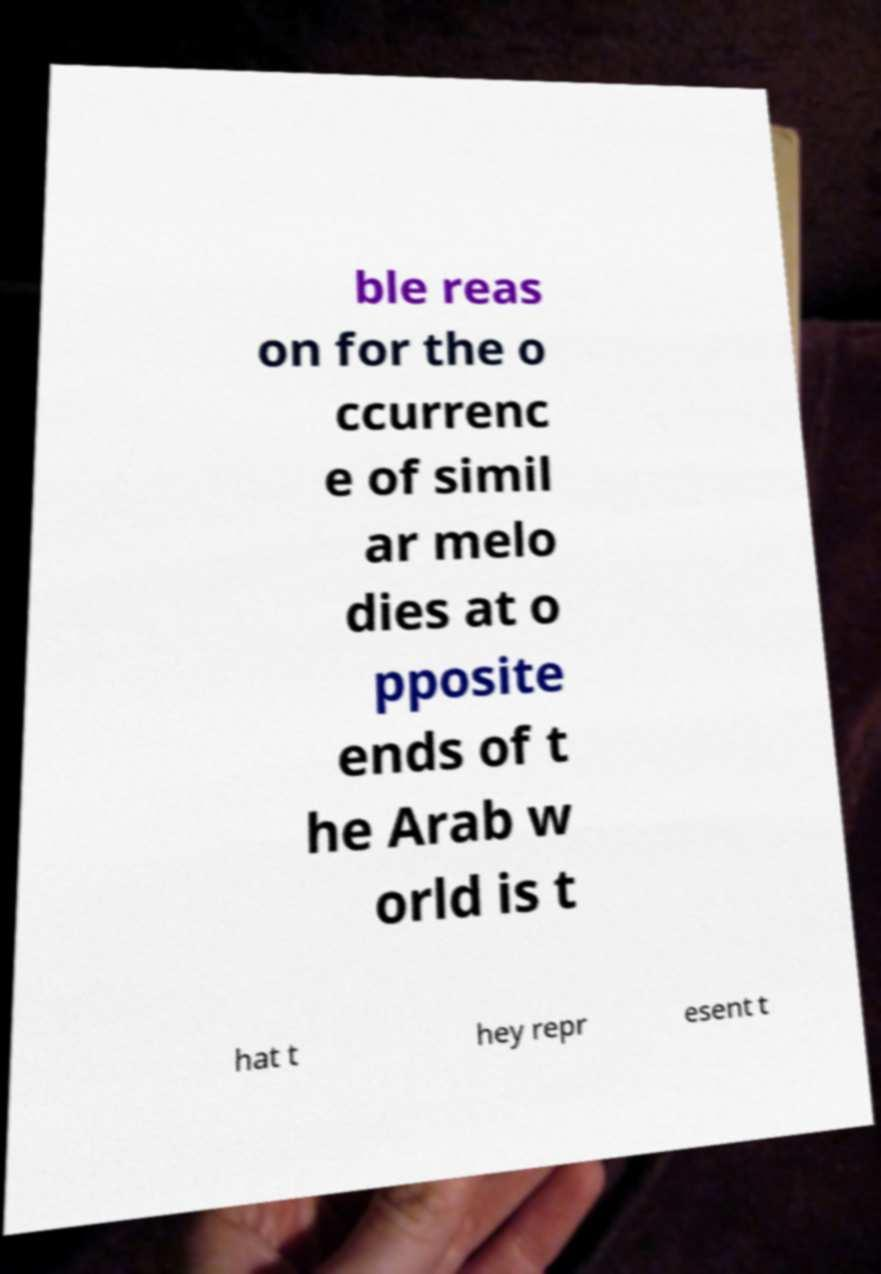What messages or text are displayed in this image? I need them in a readable, typed format. ble reas on for the o ccurrenc e of simil ar melo dies at o pposite ends of t he Arab w orld is t hat t hey repr esent t 